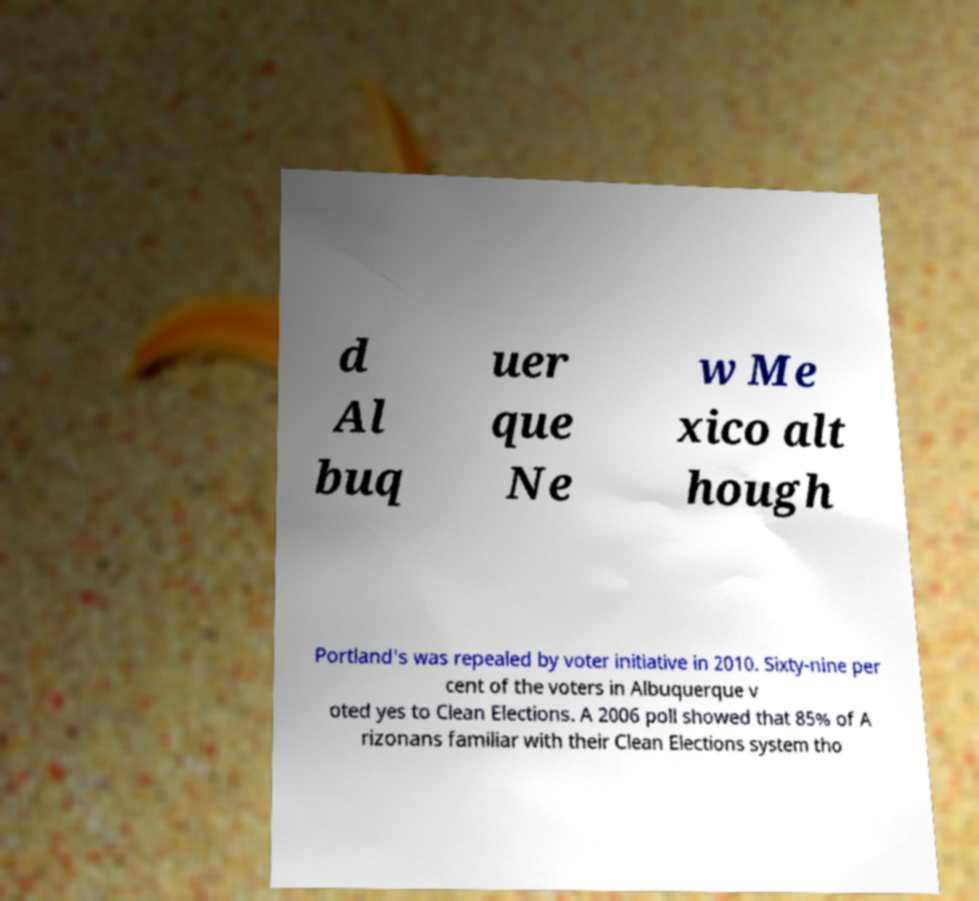For documentation purposes, I need the text within this image transcribed. Could you provide that? d Al buq uer que Ne w Me xico alt hough Portland's was repealed by voter initiative in 2010. Sixty-nine per cent of the voters in Albuquerque v oted yes to Clean Elections. A 2006 poll showed that 85% of A rizonans familiar with their Clean Elections system tho 